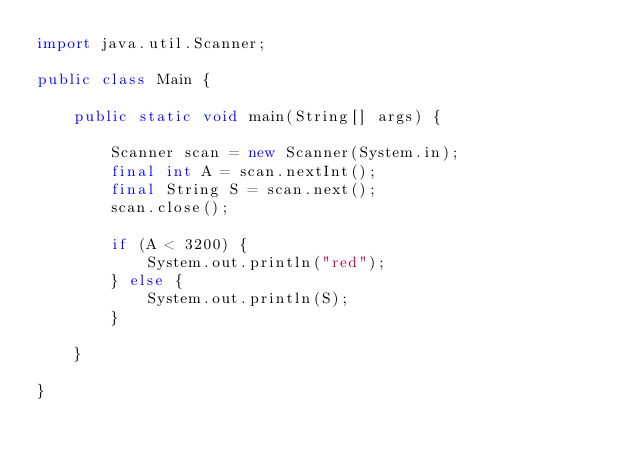<code> <loc_0><loc_0><loc_500><loc_500><_Java_>import java.util.Scanner;

public class Main {

    public static void main(String[] args) {
        
        Scanner scan = new Scanner(System.in);
        final int A = scan.nextInt();
        final String S = scan.next();
        scan.close();
        
        if (A < 3200) {
            System.out.println("red");
        } else {
            System.out.println(S);
        }

    }

}
</code> 